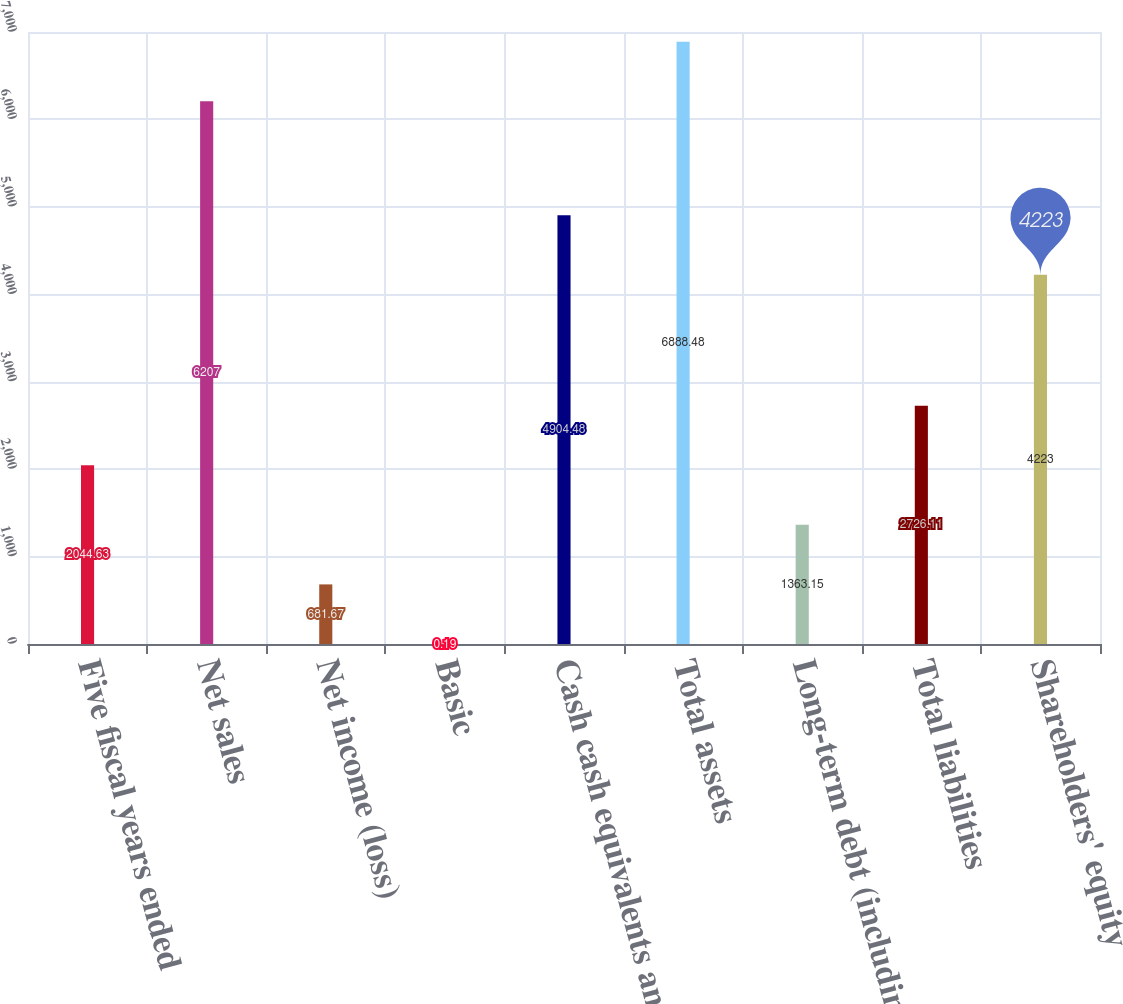Convert chart to OTSL. <chart><loc_0><loc_0><loc_500><loc_500><bar_chart><fcel>Five fiscal years ended<fcel>Net sales<fcel>Net income (loss)<fcel>Basic<fcel>Cash cash equivalents and<fcel>Total assets<fcel>Long-term debt (including<fcel>Total liabilities<fcel>Shareholders' equity<nl><fcel>2044.63<fcel>6207<fcel>681.67<fcel>0.19<fcel>4904.48<fcel>6888.48<fcel>1363.15<fcel>2726.11<fcel>4223<nl></chart> 